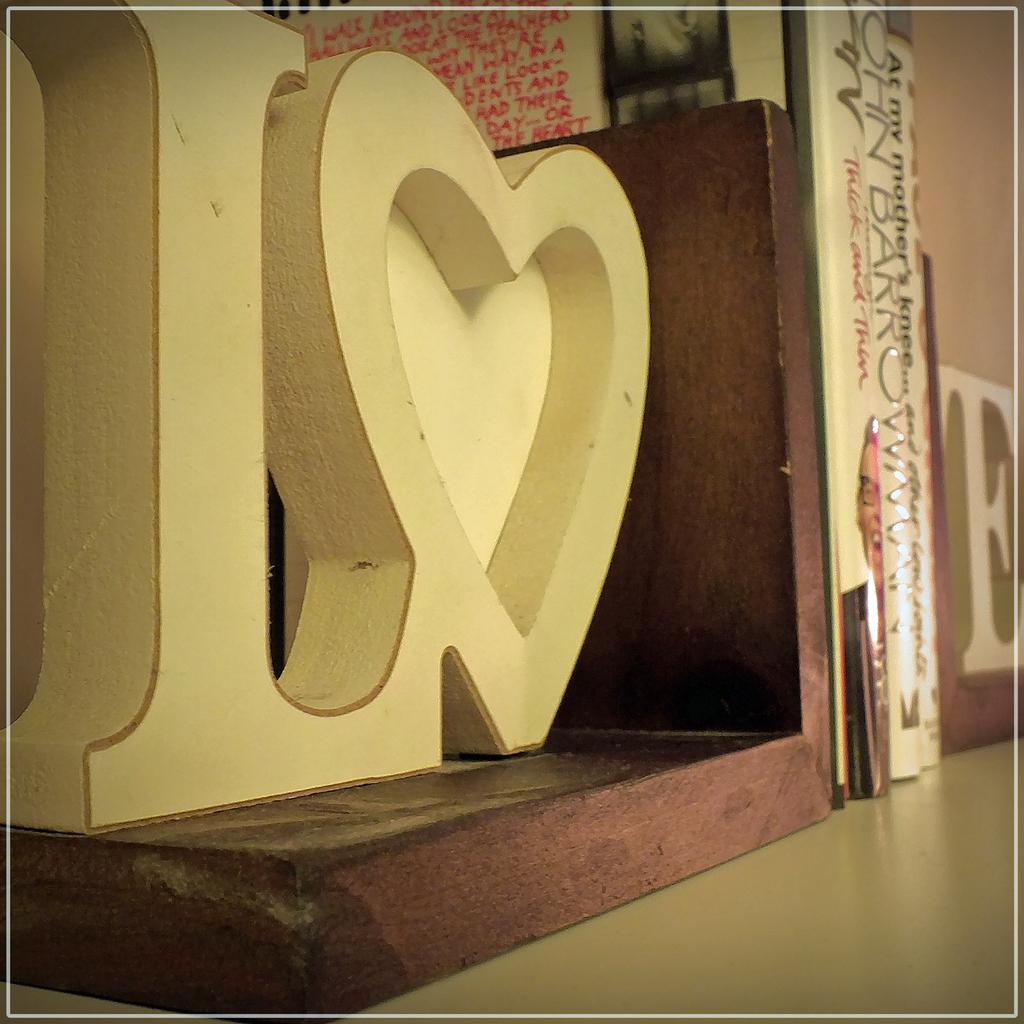<image>
Render a clear and concise summary of the photo. A bookshelf includes a book titled At My Mother's Knee. 